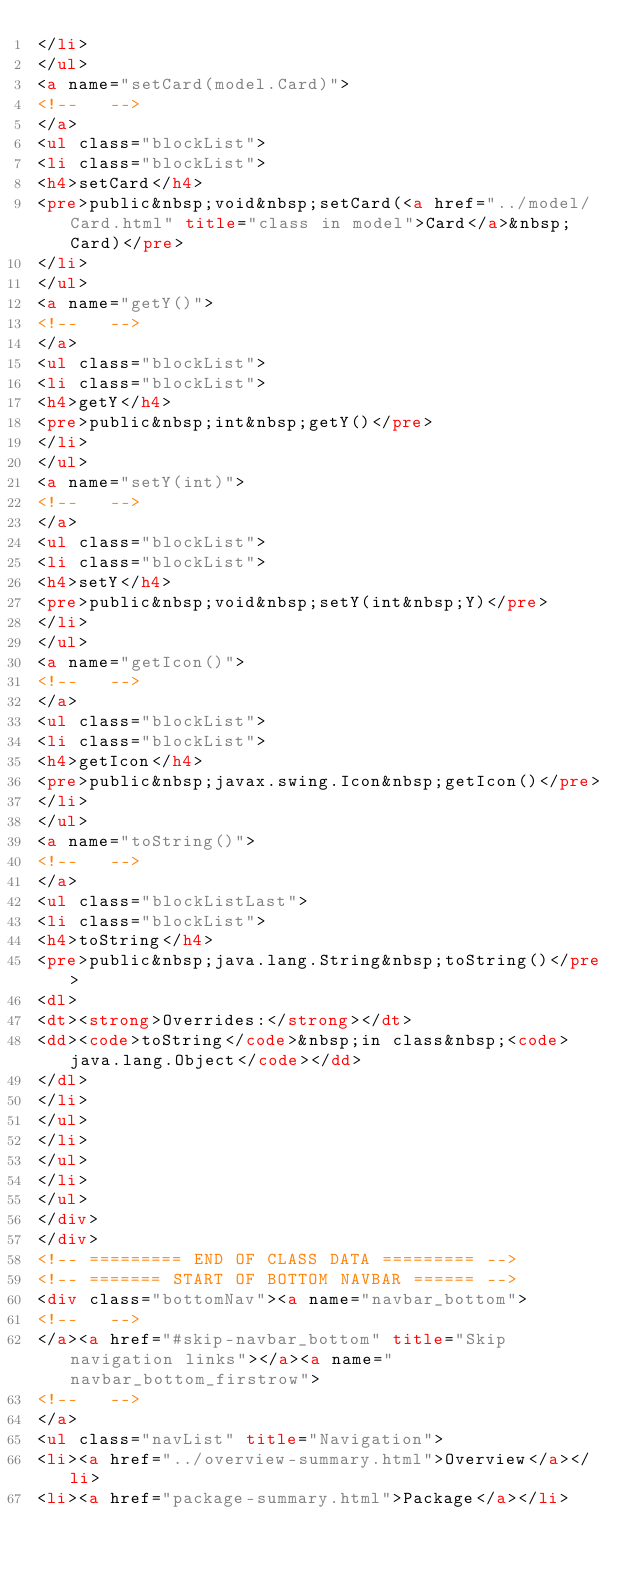<code> <loc_0><loc_0><loc_500><loc_500><_HTML_></li>
</ul>
<a name="setCard(model.Card)">
<!--   -->
</a>
<ul class="blockList">
<li class="blockList">
<h4>setCard</h4>
<pre>public&nbsp;void&nbsp;setCard(<a href="../model/Card.html" title="class in model">Card</a>&nbsp;Card)</pre>
</li>
</ul>
<a name="getY()">
<!--   -->
</a>
<ul class="blockList">
<li class="blockList">
<h4>getY</h4>
<pre>public&nbsp;int&nbsp;getY()</pre>
</li>
</ul>
<a name="setY(int)">
<!--   -->
</a>
<ul class="blockList">
<li class="blockList">
<h4>setY</h4>
<pre>public&nbsp;void&nbsp;setY(int&nbsp;Y)</pre>
</li>
</ul>
<a name="getIcon()">
<!--   -->
</a>
<ul class="blockList">
<li class="blockList">
<h4>getIcon</h4>
<pre>public&nbsp;javax.swing.Icon&nbsp;getIcon()</pre>
</li>
</ul>
<a name="toString()">
<!--   -->
</a>
<ul class="blockListLast">
<li class="blockList">
<h4>toString</h4>
<pre>public&nbsp;java.lang.String&nbsp;toString()</pre>
<dl>
<dt><strong>Overrides:</strong></dt>
<dd><code>toString</code>&nbsp;in class&nbsp;<code>java.lang.Object</code></dd>
</dl>
</li>
</ul>
</li>
</ul>
</li>
</ul>
</div>
</div>
<!-- ========= END OF CLASS DATA ========= -->
<!-- ======= START OF BOTTOM NAVBAR ====== -->
<div class="bottomNav"><a name="navbar_bottom">
<!--   -->
</a><a href="#skip-navbar_bottom" title="Skip navigation links"></a><a name="navbar_bottom_firstrow">
<!--   -->
</a>
<ul class="navList" title="Navigation">
<li><a href="../overview-summary.html">Overview</a></li>
<li><a href="package-summary.html">Package</a></li></code> 